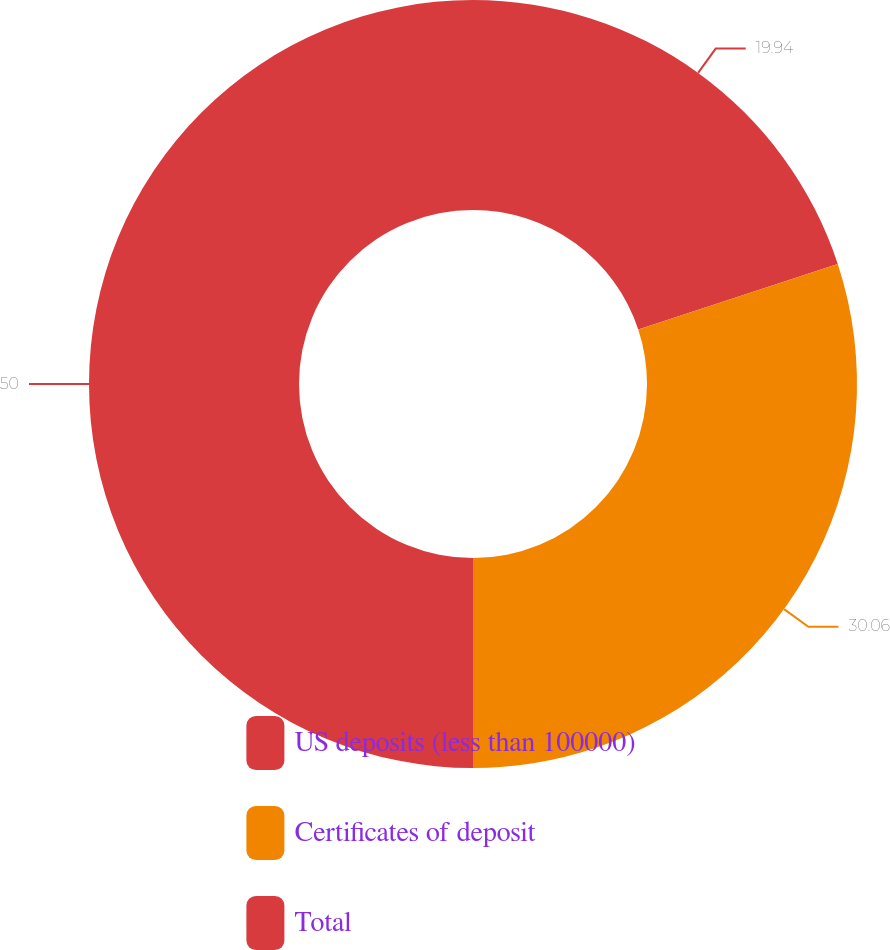Convert chart. <chart><loc_0><loc_0><loc_500><loc_500><pie_chart><fcel>US deposits (less than 100000)<fcel>Certificates of deposit<fcel>Total<nl><fcel>19.94%<fcel>30.06%<fcel>50.0%<nl></chart> 